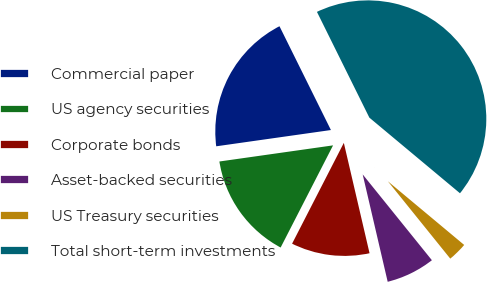Convert chart to OTSL. <chart><loc_0><loc_0><loc_500><loc_500><pie_chart><fcel>Commercial paper<fcel>US agency securities<fcel>Corporate bonds<fcel>Asset-backed securities<fcel>US Treasury securities<fcel>Total short-term investments<nl><fcel>19.92%<fcel>15.21%<fcel>11.19%<fcel>7.16%<fcel>3.13%<fcel>43.39%<nl></chart> 